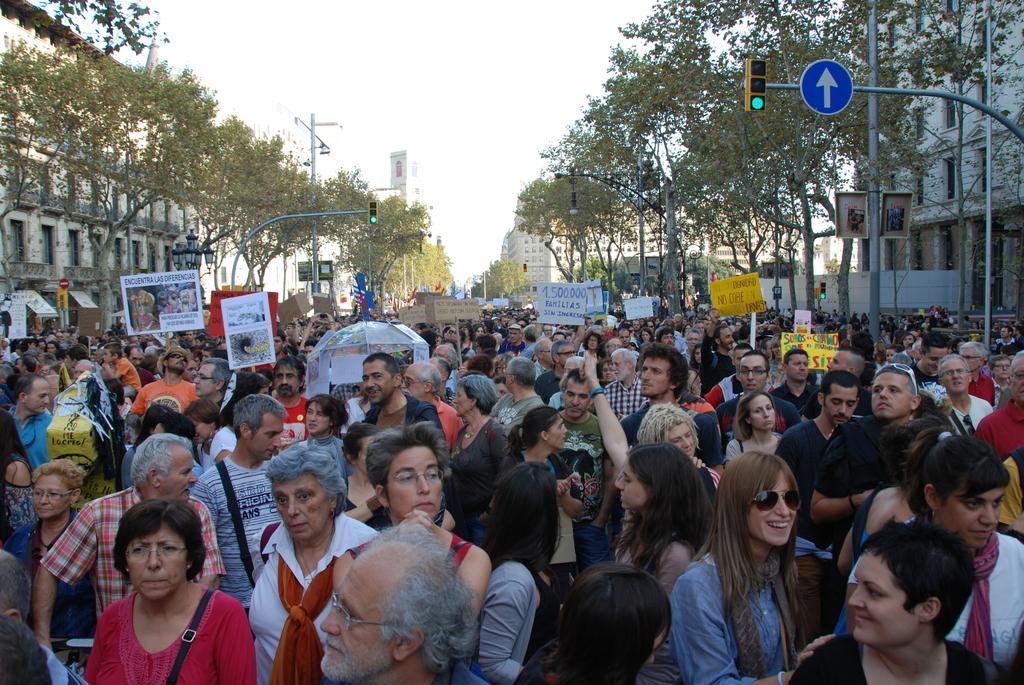Could you give a brief overview of what you see in this image? In front of the image there are people holding the placards. There are traffic lights, directional boards, light poles. In the background of the image there are buildings, trees. At the top of the image there is sky. 